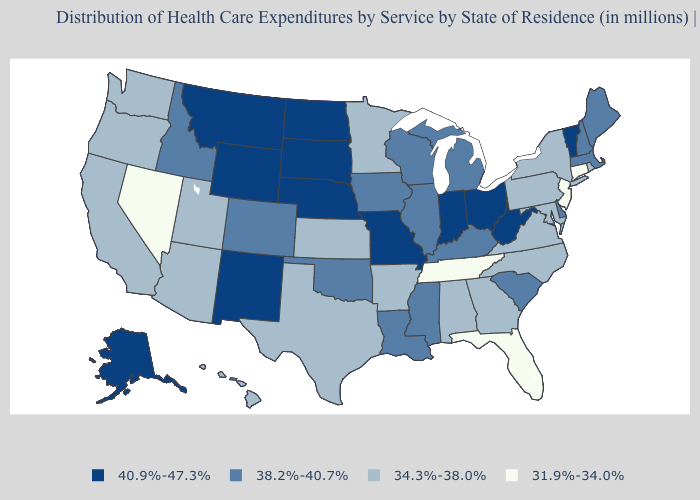Among the states that border Indiana , which have the highest value?
Answer briefly. Ohio. What is the value of Utah?
Short answer required. 34.3%-38.0%. Does Delaware have a lower value than Ohio?
Write a very short answer. Yes. What is the value of Wyoming?
Write a very short answer. 40.9%-47.3%. Name the states that have a value in the range 34.3%-38.0%?
Give a very brief answer. Alabama, Arizona, Arkansas, California, Georgia, Hawaii, Kansas, Maryland, Minnesota, New York, North Carolina, Oregon, Pennsylvania, Rhode Island, Texas, Utah, Virginia, Washington. Does Arkansas have a higher value than Louisiana?
Short answer required. No. Name the states that have a value in the range 40.9%-47.3%?
Short answer required. Alaska, Indiana, Missouri, Montana, Nebraska, New Mexico, North Dakota, Ohio, South Dakota, Vermont, West Virginia, Wyoming. What is the value of Maryland?
Answer briefly. 34.3%-38.0%. Name the states that have a value in the range 40.9%-47.3%?
Concise answer only. Alaska, Indiana, Missouri, Montana, Nebraska, New Mexico, North Dakota, Ohio, South Dakota, Vermont, West Virginia, Wyoming. Name the states that have a value in the range 34.3%-38.0%?
Short answer required. Alabama, Arizona, Arkansas, California, Georgia, Hawaii, Kansas, Maryland, Minnesota, New York, North Carolina, Oregon, Pennsylvania, Rhode Island, Texas, Utah, Virginia, Washington. What is the lowest value in the South?
Concise answer only. 31.9%-34.0%. Name the states that have a value in the range 38.2%-40.7%?
Give a very brief answer. Colorado, Delaware, Idaho, Illinois, Iowa, Kentucky, Louisiana, Maine, Massachusetts, Michigan, Mississippi, New Hampshire, Oklahoma, South Carolina, Wisconsin. What is the highest value in the Northeast ?
Quick response, please. 40.9%-47.3%. Name the states that have a value in the range 38.2%-40.7%?
Keep it brief. Colorado, Delaware, Idaho, Illinois, Iowa, Kentucky, Louisiana, Maine, Massachusetts, Michigan, Mississippi, New Hampshire, Oklahoma, South Carolina, Wisconsin. What is the value of North Carolina?
Concise answer only. 34.3%-38.0%. 